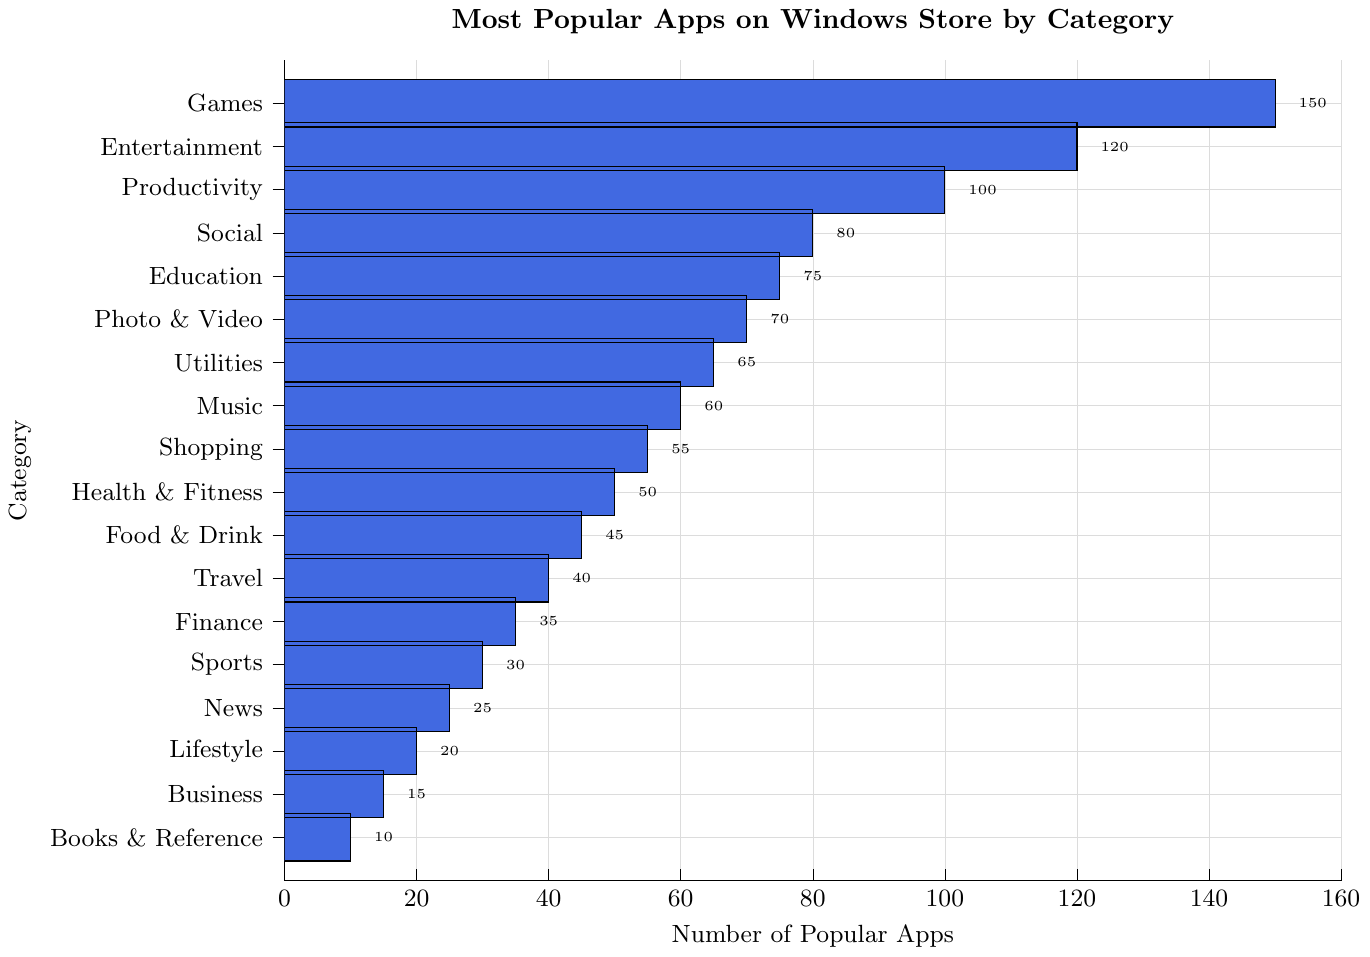What category has the highest number of popular apps? The bar for the "Games" category is the longest.
Answer: Games Which two categories combined have exactly 165 popular apps? The categories "Games" and "Health & Fitness" have 150 and 50 apps, respectively. Summing them up gives 150 + 50 = 200. Try another combination, "Entertainment" and "Food & Drink" (120 + 45 = 165).
Answer: Entertainment and Food & Drink What is the average number of popular apps in the top 3 categories? The top 3 categories are "Games" (150), "Entertainment" (120), and "Productivity" (100). Calculating the average: (150 + 120 + 100) / 3 = 370 / 3 ≈ 123.33
Answer: ≈ 123.33 Is the number of popular apps in the "Education" category more than "Health & Fitness"? The bar for "Education" (75) is higher than "Health & Fitness" (50).
Answer: Yes How many more popular apps does the "Photo & Video" category have compared to the "Finance" category? The number of apps in "Photo & Video" is 70, and in "Finance" is 35. The difference is 70 - 35 = 35.
Answer: 35 What category has just half the number of popular apps compared to "Games"? "Games" has 150 apps. Half of 150 is 75, which corresponds to the "Education" category.
Answer: Education Which categories have fewer than 30 popular apps? The bars for "Sports" (30), "News" (25), "Lifestyle" (20), "Business" (15), and "Books & Reference" (10) are shorter and below 30.
Answer: News, Lifestyle, Business, Books & Reference What is the difference in the number of popular apps between the categories with the most and the least apps? "Games" have the most with 150 apps, and "Books & Reference" have the least with 10 apps. The difference is 150 - 10 = 140.
Answer: 140 Which category appears exactly in the middle in terms of the number of popular apps listed? With 18 categories, the middle one would technically be the 9th and 10th when listed in numerical order. The 9th category is "Shopping" (55).
Answer: Shopping 